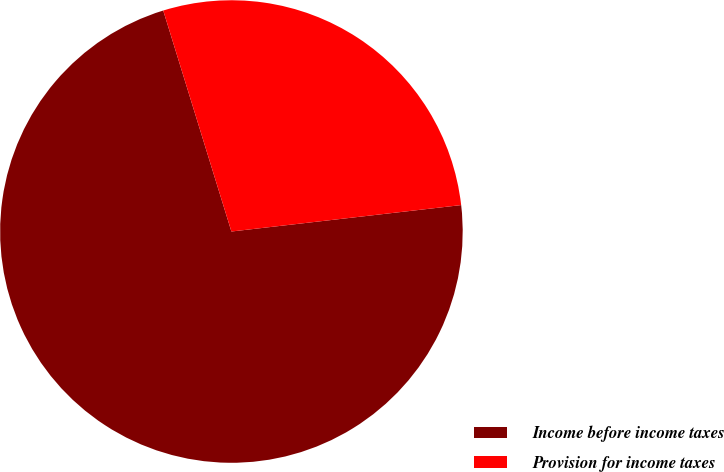Convert chart. <chart><loc_0><loc_0><loc_500><loc_500><pie_chart><fcel>Income before income taxes<fcel>Provision for income taxes<nl><fcel>72.06%<fcel>27.94%<nl></chart> 